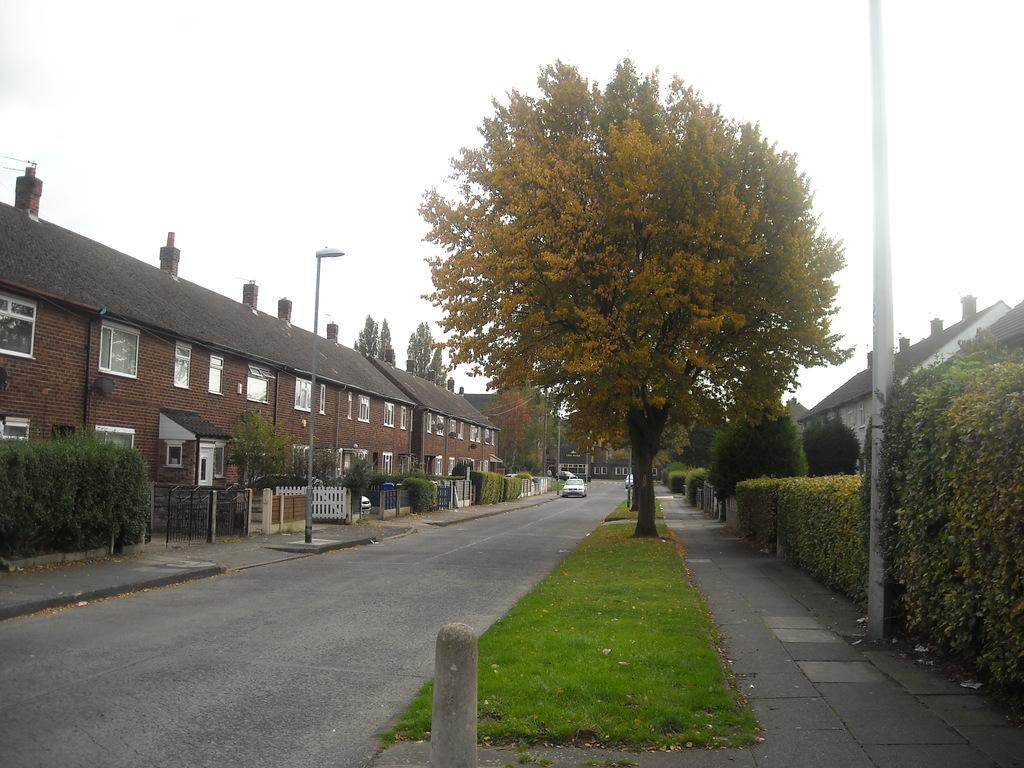In one or two sentences, can you explain what this image depicts? In the picture we can see a road on the either sides on the middle we can see a grass path and trees on it and on the either sides of the road we can see the poles, plants and a building which is brown in color with a window and trees and in the background we can also see a sky. 